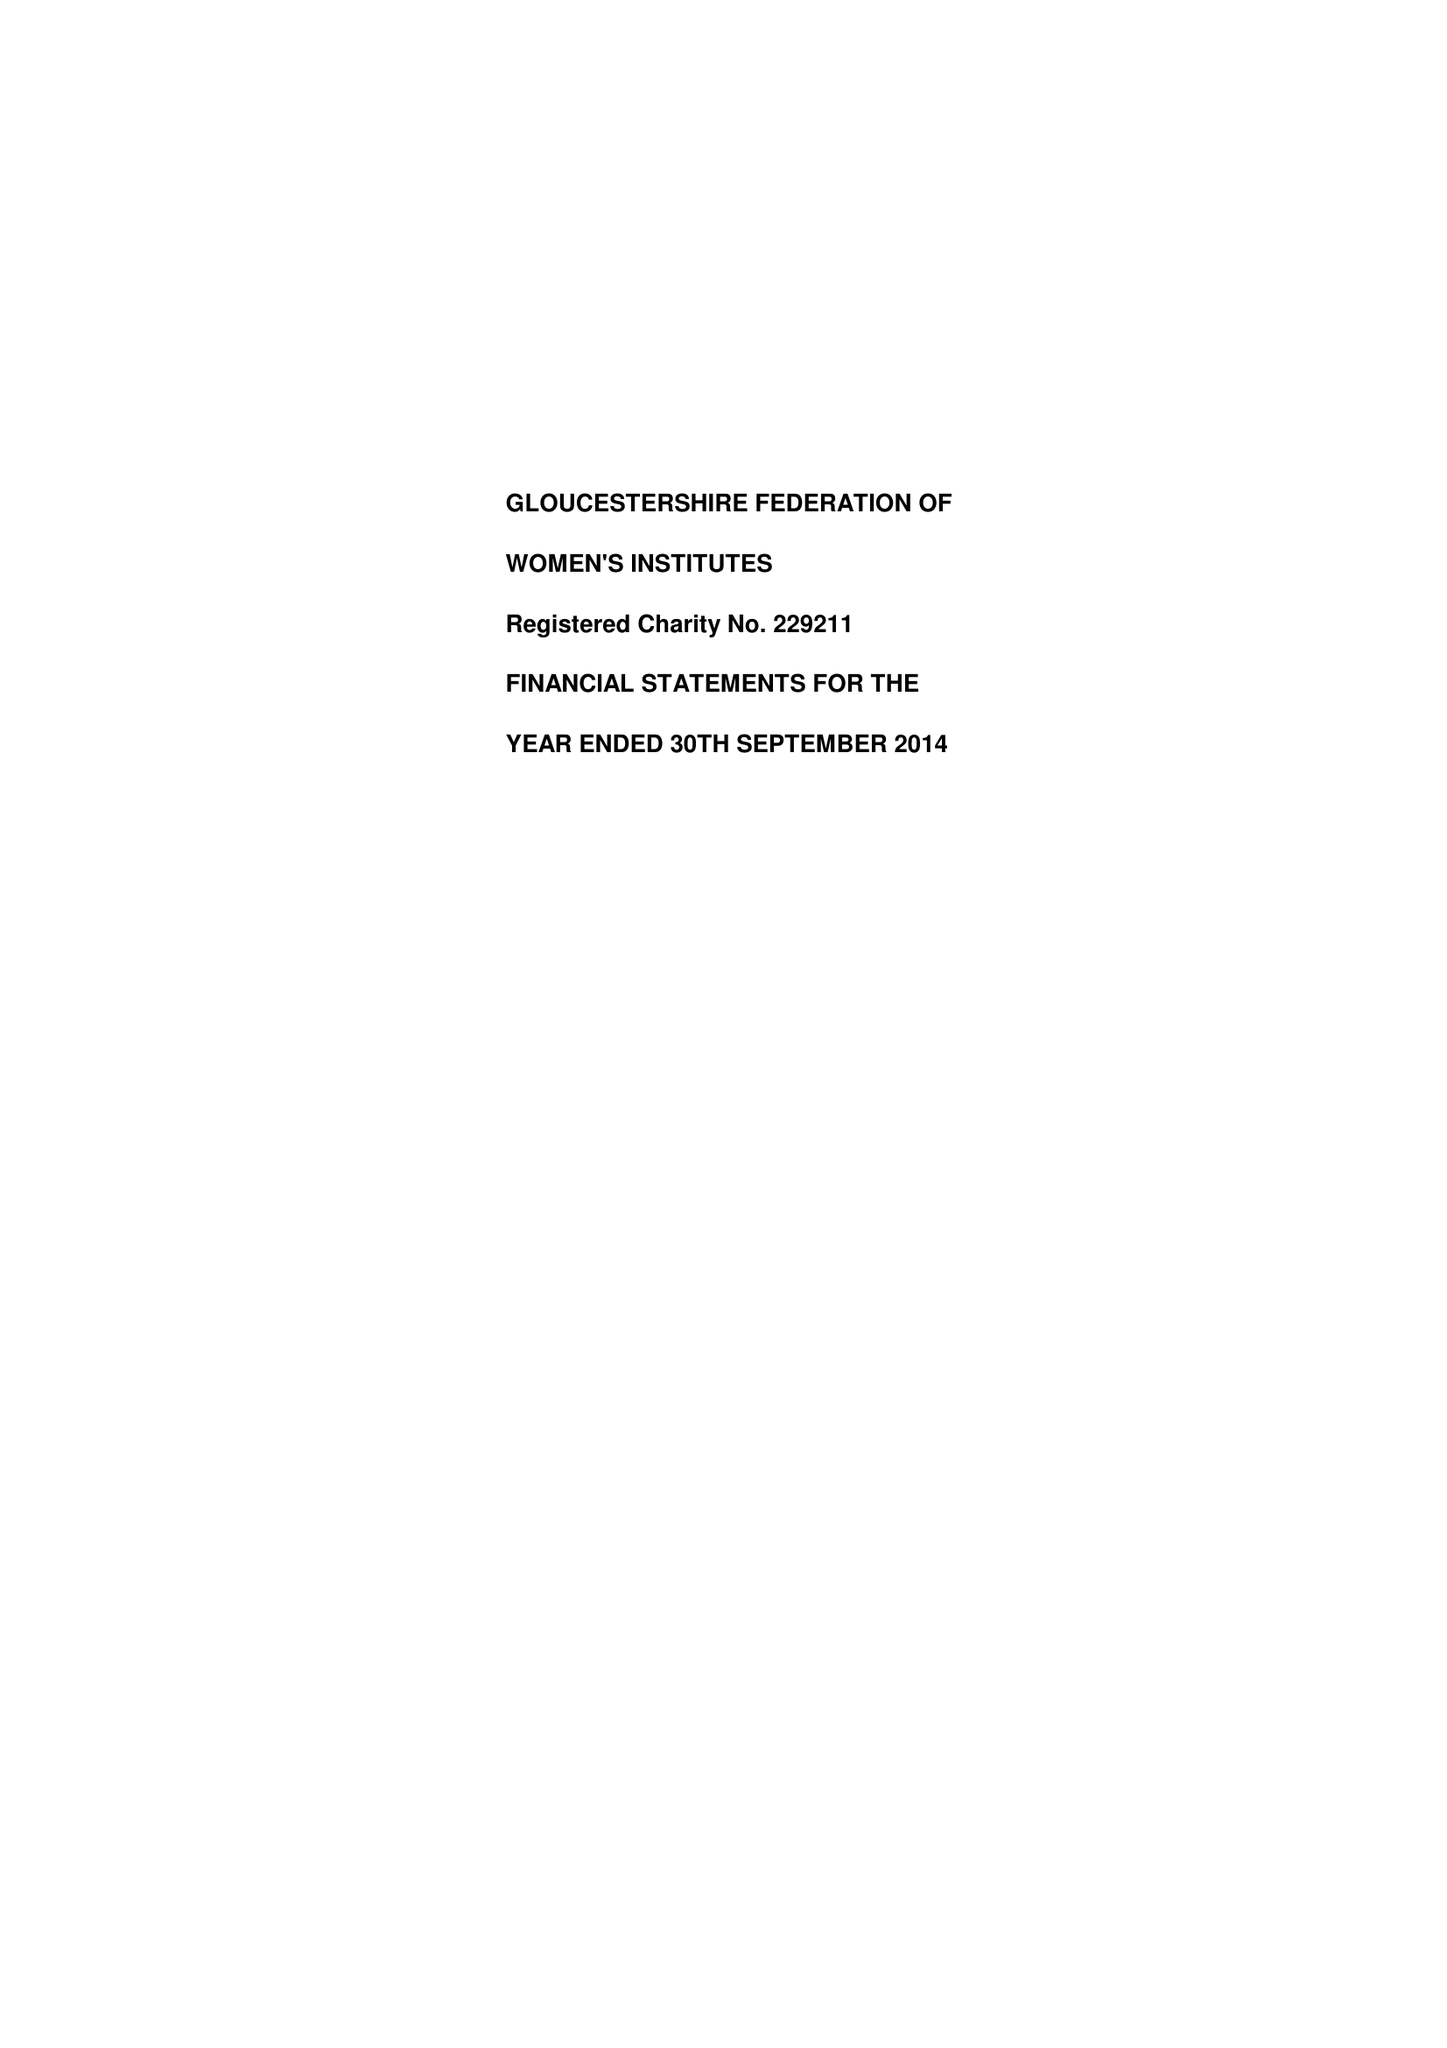What is the value for the address__post_town?
Answer the question using a single word or phrase. GLOUCESTER 